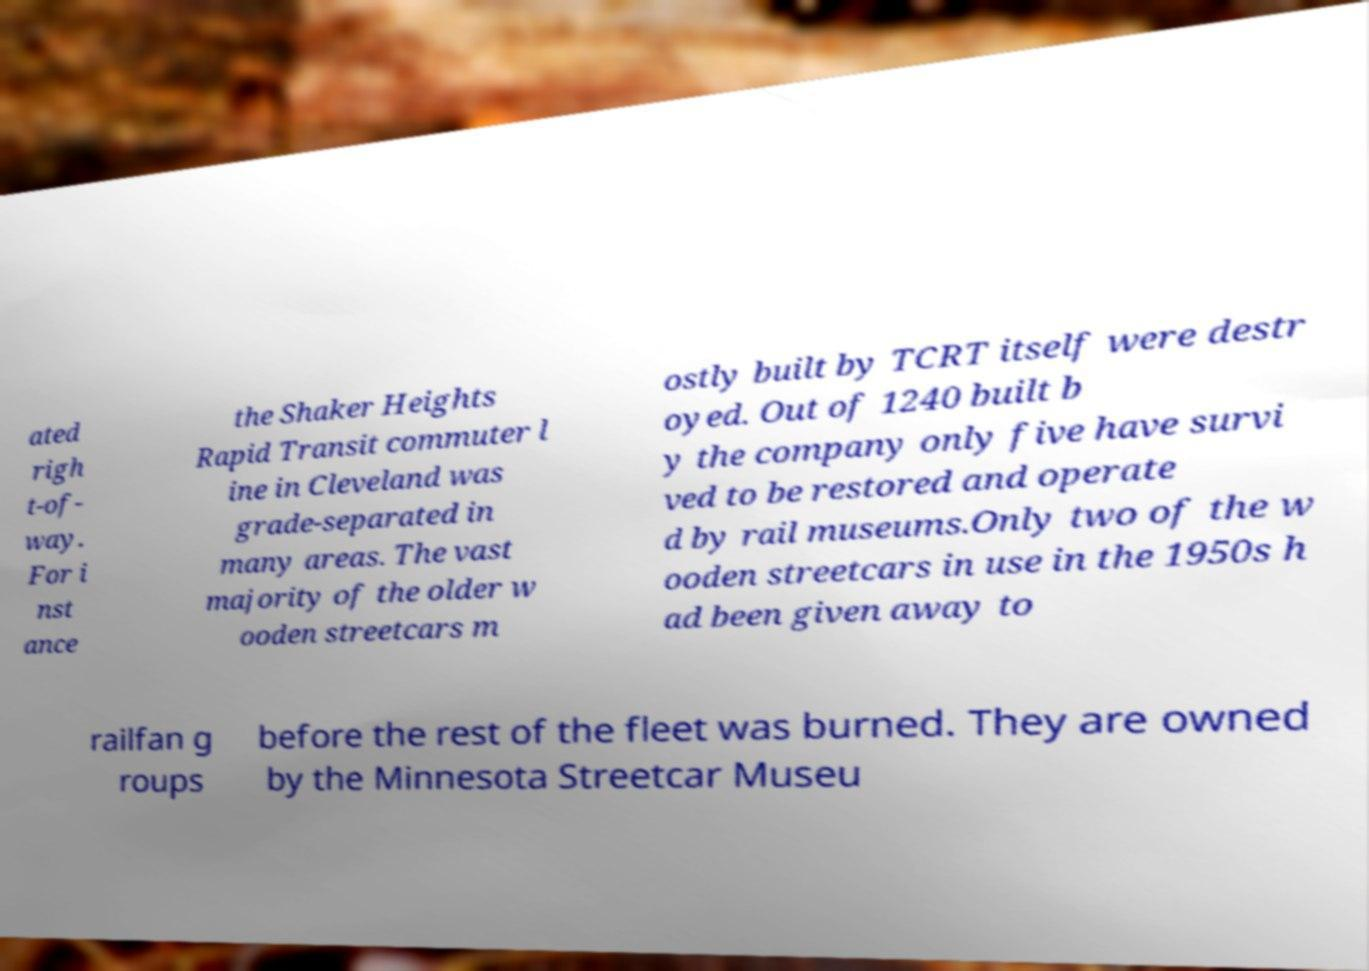Please identify and transcribe the text found in this image. ated righ t-of- way. For i nst ance the Shaker Heights Rapid Transit commuter l ine in Cleveland was grade-separated in many areas. The vast majority of the older w ooden streetcars m ostly built by TCRT itself were destr oyed. Out of 1240 built b y the company only five have survi ved to be restored and operate d by rail museums.Only two of the w ooden streetcars in use in the 1950s h ad been given away to railfan g roups before the rest of the fleet was burned. They are owned by the Minnesota Streetcar Museu 